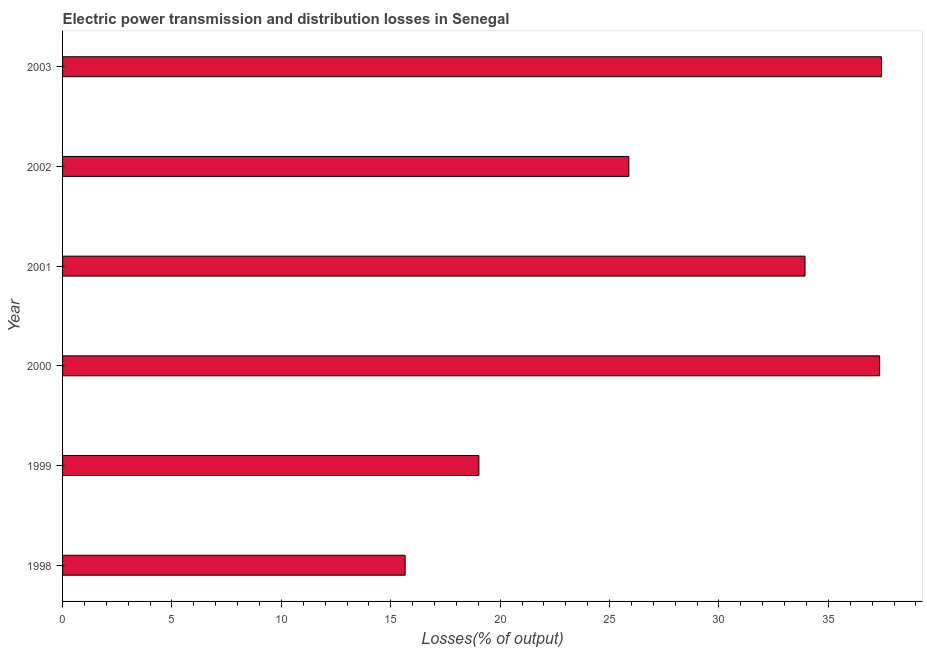Does the graph contain any zero values?
Provide a succinct answer. No. Does the graph contain grids?
Your response must be concise. No. What is the title of the graph?
Offer a terse response. Electric power transmission and distribution losses in Senegal. What is the label or title of the X-axis?
Make the answer very short. Losses(% of output). What is the electric power transmission and distribution losses in 2001?
Your response must be concise. 33.93. Across all years, what is the maximum electric power transmission and distribution losses?
Keep it short and to the point. 37.43. Across all years, what is the minimum electric power transmission and distribution losses?
Offer a very short reply. 15.66. What is the sum of the electric power transmission and distribution losses?
Offer a very short reply. 169.27. What is the difference between the electric power transmission and distribution losses in 1998 and 2003?
Give a very brief answer. -21.77. What is the average electric power transmission and distribution losses per year?
Provide a succinct answer. 28.21. What is the median electric power transmission and distribution losses?
Your answer should be very brief. 29.91. What is the ratio of the electric power transmission and distribution losses in 2002 to that in 2003?
Give a very brief answer. 0.69. Is the electric power transmission and distribution losses in 1998 less than that in 2003?
Give a very brief answer. Yes. What is the difference between the highest and the second highest electric power transmission and distribution losses?
Give a very brief answer. 0.09. Is the sum of the electric power transmission and distribution losses in 1998 and 1999 greater than the maximum electric power transmission and distribution losses across all years?
Your response must be concise. No. What is the difference between the highest and the lowest electric power transmission and distribution losses?
Offer a terse response. 21.77. How many bars are there?
Provide a short and direct response. 6. What is the difference between two consecutive major ticks on the X-axis?
Ensure brevity in your answer.  5. What is the Losses(% of output) of 1998?
Your answer should be compact. 15.66. What is the Losses(% of output) of 1999?
Your response must be concise. 19.03. What is the Losses(% of output) of 2000?
Your answer should be compact. 37.34. What is the Losses(% of output) in 2001?
Give a very brief answer. 33.93. What is the Losses(% of output) of 2002?
Offer a very short reply. 25.88. What is the Losses(% of output) in 2003?
Make the answer very short. 37.43. What is the difference between the Losses(% of output) in 1998 and 1999?
Offer a very short reply. -3.37. What is the difference between the Losses(% of output) in 1998 and 2000?
Offer a terse response. -21.69. What is the difference between the Losses(% of output) in 1998 and 2001?
Keep it short and to the point. -18.28. What is the difference between the Losses(% of output) in 1998 and 2002?
Give a very brief answer. -10.22. What is the difference between the Losses(% of output) in 1998 and 2003?
Ensure brevity in your answer.  -21.77. What is the difference between the Losses(% of output) in 1999 and 2000?
Offer a very short reply. -18.32. What is the difference between the Losses(% of output) in 1999 and 2001?
Keep it short and to the point. -14.91. What is the difference between the Losses(% of output) in 1999 and 2002?
Provide a short and direct response. -6.85. What is the difference between the Losses(% of output) in 1999 and 2003?
Ensure brevity in your answer.  -18.4. What is the difference between the Losses(% of output) in 2000 and 2001?
Your answer should be very brief. 3.41. What is the difference between the Losses(% of output) in 2000 and 2002?
Your answer should be compact. 11.46. What is the difference between the Losses(% of output) in 2000 and 2003?
Give a very brief answer. -0.09. What is the difference between the Losses(% of output) in 2001 and 2002?
Ensure brevity in your answer.  8.05. What is the difference between the Losses(% of output) in 2001 and 2003?
Make the answer very short. -3.5. What is the difference between the Losses(% of output) in 2002 and 2003?
Make the answer very short. -11.55. What is the ratio of the Losses(% of output) in 1998 to that in 1999?
Make the answer very short. 0.82. What is the ratio of the Losses(% of output) in 1998 to that in 2000?
Provide a short and direct response. 0.42. What is the ratio of the Losses(% of output) in 1998 to that in 2001?
Your answer should be compact. 0.46. What is the ratio of the Losses(% of output) in 1998 to that in 2002?
Give a very brief answer. 0.6. What is the ratio of the Losses(% of output) in 1998 to that in 2003?
Provide a short and direct response. 0.42. What is the ratio of the Losses(% of output) in 1999 to that in 2000?
Your response must be concise. 0.51. What is the ratio of the Losses(% of output) in 1999 to that in 2001?
Your answer should be compact. 0.56. What is the ratio of the Losses(% of output) in 1999 to that in 2002?
Your answer should be very brief. 0.73. What is the ratio of the Losses(% of output) in 1999 to that in 2003?
Make the answer very short. 0.51. What is the ratio of the Losses(% of output) in 2000 to that in 2001?
Make the answer very short. 1.1. What is the ratio of the Losses(% of output) in 2000 to that in 2002?
Offer a very short reply. 1.44. What is the ratio of the Losses(% of output) in 2001 to that in 2002?
Keep it short and to the point. 1.31. What is the ratio of the Losses(% of output) in 2001 to that in 2003?
Offer a terse response. 0.91. What is the ratio of the Losses(% of output) in 2002 to that in 2003?
Provide a short and direct response. 0.69. 